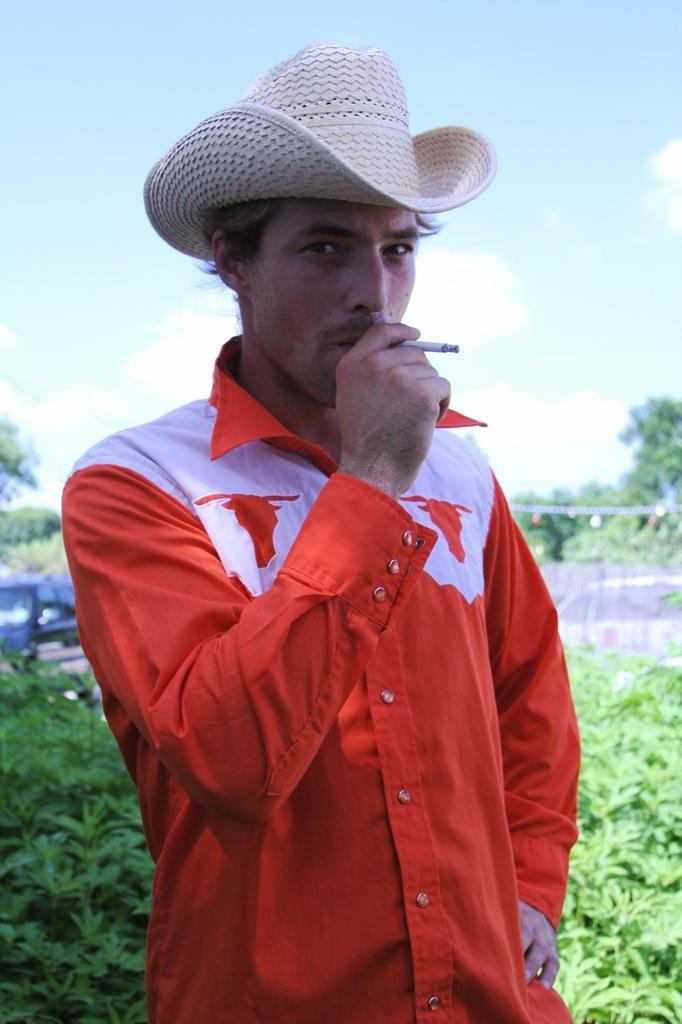In one or two sentences, can you explain what this image depicts? In this image we can see a man is standing. He is wearing a shirt, hat and holding a cigarette in his hand. In the background, we can see greenery, car and the sky with clouds. 